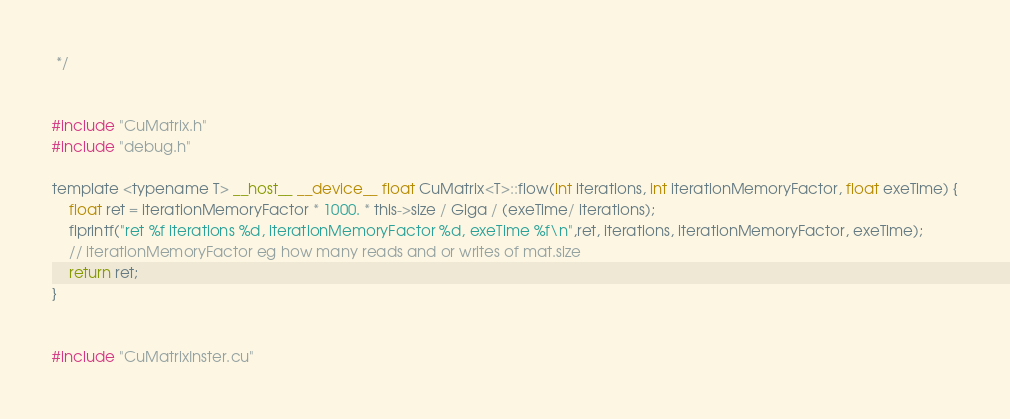<code> <loc_0><loc_0><loc_500><loc_500><_Cuda_> */


#include "CuMatrix.h"
#include "debug.h"

template <typename T> __host__ __device__ float CuMatrix<T>::flow(int iterations, int iterationMemoryFactor, float exeTime) {
	float ret = iterationMemoryFactor * 1000. * this->size / Giga / (exeTime/ iterations);
	flprintf("ret %f iterations %d, iterationMemoryFactor %d, exeTime %f\n",ret, iterations, iterationMemoryFactor, exeTime);
	// iterationMemoryFactor eg how many reads and or writes of mat.size
	return ret;
}


#include "CuMatrixInster.cu"
</code> 